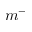<formula> <loc_0><loc_0><loc_500><loc_500>m ^ { - }</formula> 